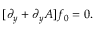<formula> <loc_0><loc_0><loc_500><loc_500>[ \partial _ { y } + \partial _ { y } A ] f _ { 0 } = 0 .</formula> 